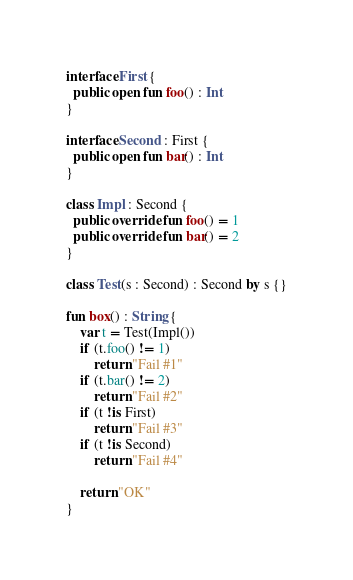Convert code to text. <code><loc_0><loc_0><loc_500><loc_500><_Kotlin_>interface First {
  public open fun foo() : Int
}

interface Second : First {
  public open fun bar() : Int
}

class Impl : Second {
  public override fun foo() = 1
  public override fun bar() = 2
}

class Test(s : Second) : Second by s {}

fun box() : String {
    var t = Test(Impl())
    if (t.foo() != 1)
        return "Fail #1"
    if (t.bar() != 2)
        return "Fail #2"
    if (t !is First)
        return "Fail #3"
    if (t !is Second)
        return "Fail #4"

    return "OK"
}
</code> 